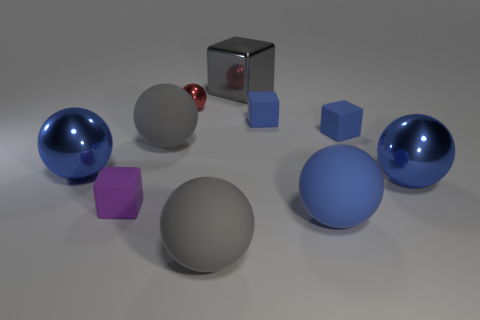What number of other things are there of the same shape as the tiny shiny object?
Ensure brevity in your answer.  5. How many gray things are either tiny matte objects or large metal spheres?
Make the answer very short. 0. Does the small metal thing have the same shape as the purple rubber thing?
Provide a succinct answer. No. Is there a object that is in front of the gray thing on the left side of the small red shiny object?
Provide a short and direct response. Yes. Is the number of small purple blocks left of the large blue rubber object the same as the number of blue blocks?
Provide a succinct answer. No. How many other things are the same size as the gray metal thing?
Make the answer very short. 5. Does the blue ball that is to the left of the big gray metal cube have the same material as the big blue thing to the right of the blue matte ball?
Provide a succinct answer. Yes. What is the size of the ball in front of the big rubber sphere to the right of the big gray block?
Provide a succinct answer. Large. Is there a small rubber sphere of the same color as the tiny metallic object?
Provide a succinct answer. No. There is a big shiny ball that is to the left of the metal cube; is it the same color as the small matte object that is to the left of the gray shiny cube?
Offer a terse response. No. 